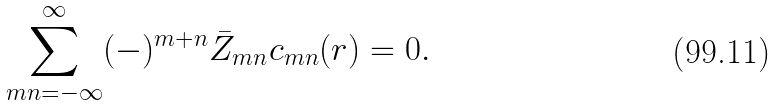Convert formula to latex. <formula><loc_0><loc_0><loc_500><loc_500>\sum _ { m n = - \infty } ^ { \infty } ( - ) ^ { m + n } { \bar { Z } } _ { m n } c _ { m n } ( { r } ) = 0 .</formula> 